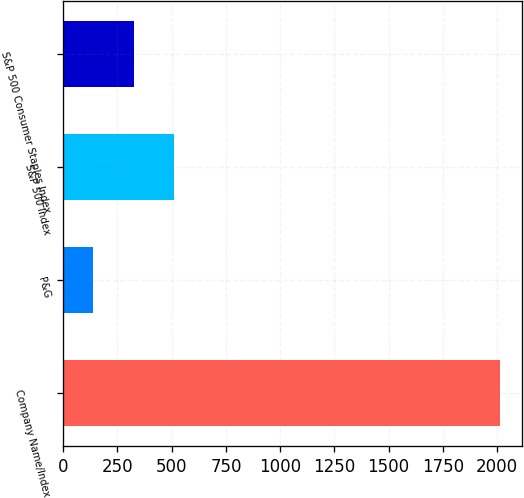Convert chart. <chart><loc_0><loc_0><loc_500><loc_500><bar_chart><fcel>Company Name/Index<fcel>P&G<fcel>S&P 500 Index<fcel>S&P 500 Consumer Staples Index<nl><fcel>2014<fcel>136<fcel>511.6<fcel>323.8<nl></chart> 